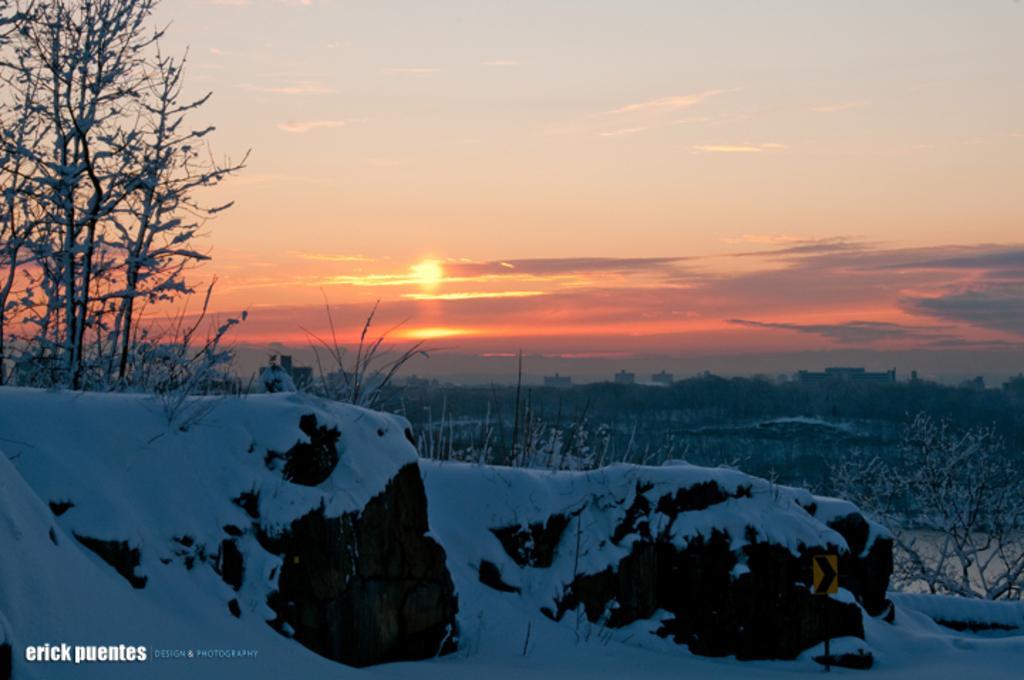Describe this image in one or two sentences. In the image I can see the snow and trees. There is a sky on the top of this image. 